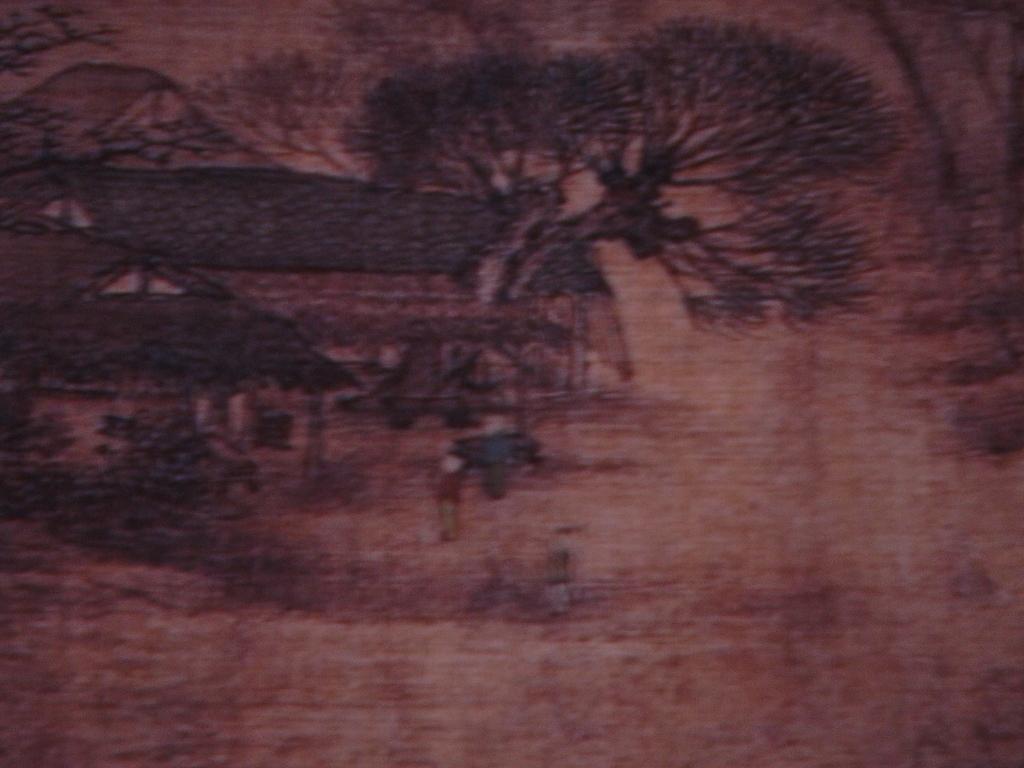Describe this image in one or two sentences. This picture is dark and slightly blurred where we can see an art of houses and trees which in brown color. 